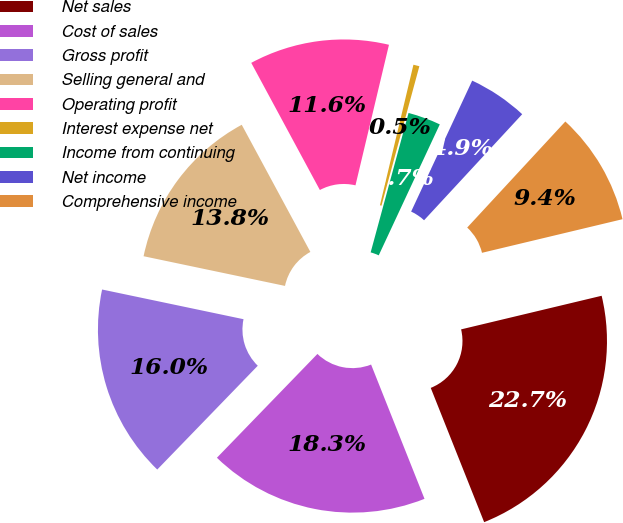Convert chart to OTSL. <chart><loc_0><loc_0><loc_500><loc_500><pie_chart><fcel>Net sales<fcel>Cost of sales<fcel>Gross profit<fcel>Selling general and<fcel>Operating profit<fcel>Interest expense net<fcel>Income from continuing<fcel>Net income<fcel>Comprehensive income<nl><fcel>22.71%<fcel>18.27%<fcel>16.05%<fcel>13.83%<fcel>11.6%<fcel>0.5%<fcel>2.72%<fcel>4.94%<fcel>9.38%<nl></chart> 